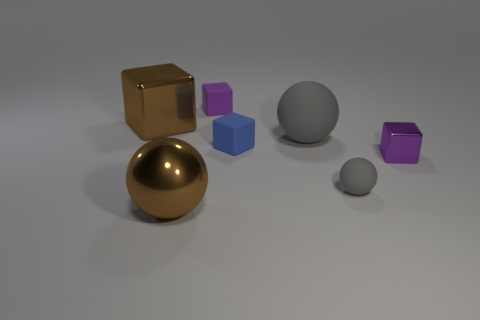What is the size of the matte thing that is the same color as the tiny metallic cube?
Keep it short and to the point. Small. There is a object left of the brown metal ball; is its color the same as the large shiny sphere?
Your answer should be very brief. Yes. What number of objects are either big brown things behind the big brown metal ball or tiny cubes behind the large brown shiny cube?
Offer a terse response. 2. What number of blocks are left of the small purple shiny thing and on the right side of the brown metallic block?
Provide a succinct answer. 2. Are the brown sphere and the large brown block made of the same material?
Give a very brief answer. Yes. There is a small purple object that is in front of the gray rubber thing behind the purple object on the right side of the purple matte block; what shape is it?
Keep it short and to the point. Cube. There is a object that is both left of the tiny ball and in front of the small metallic object; what is its material?
Offer a terse response. Metal. The metallic block on the right side of the small block that is behind the metal object that is on the left side of the brown sphere is what color?
Provide a short and direct response. Purple. What number of red things are small shiny things or large metal spheres?
Ensure brevity in your answer.  0. What number of other objects are there of the same size as the brown metal block?
Offer a very short reply. 2. 